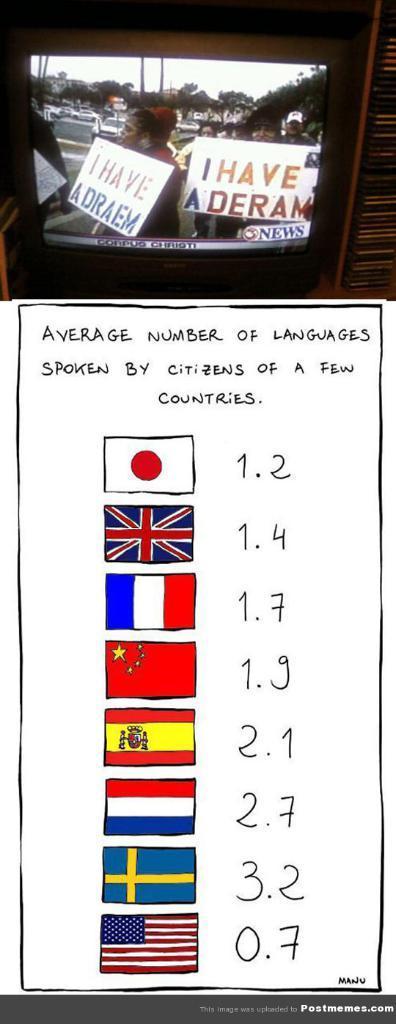Can you describe this image briefly? In this image we can see there is a television. In the television we can see people, boards, cars and objects. There is something written on the board. At the bottom there is text and symbols of country flags. 